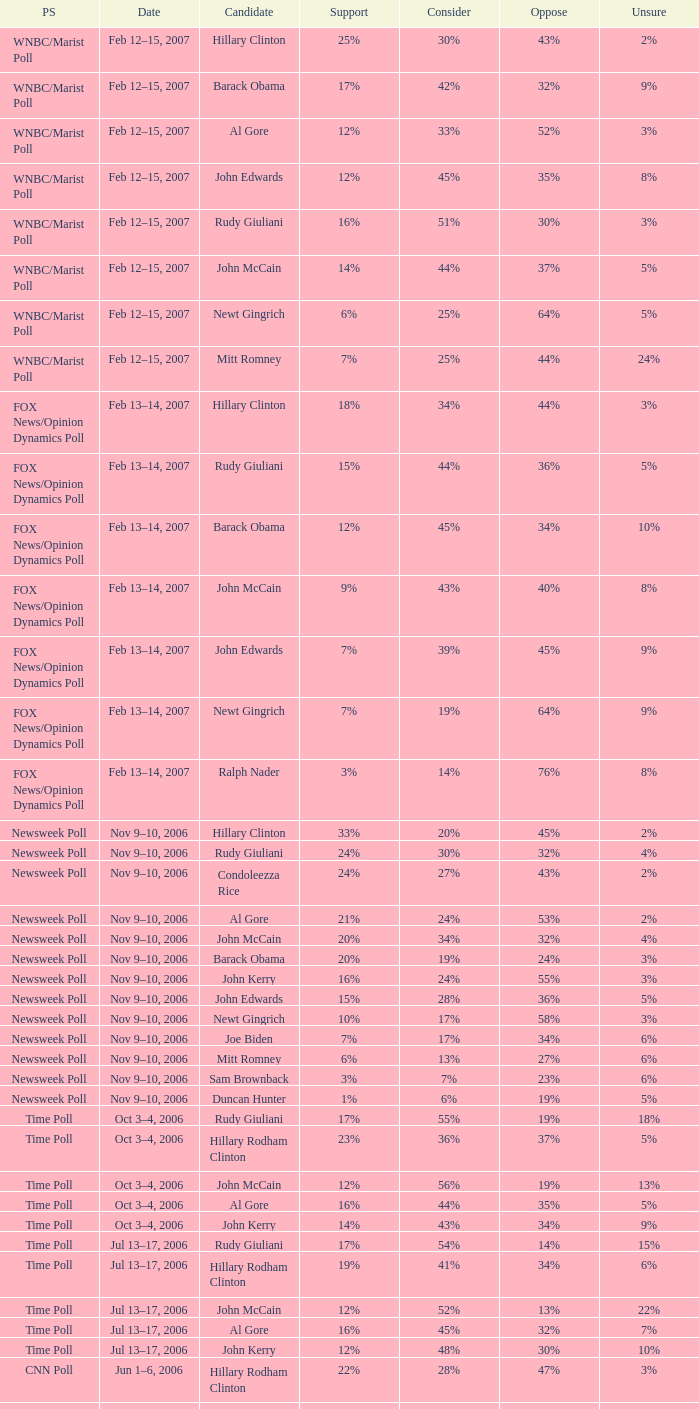What percentage of people were opposed to the candidate based on the WNBC/Marist poll that showed 8% of people were unsure? 35%. Could you parse the entire table? {'header': ['PS', 'Date', 'Candidate', 'Support', 'Consider', 'Oppose', 'Unsure'], 'rows': [['WNBC/Marist Poll', 'Feb 12–15, 2007', 'Hillary Clinton', '25%', '30%', '43%', '2%'], ['WNBC/Marist Poll', 'Feb 12–15, 2007', 'Barack Obama', '17%', '42%', '32%', '9%'], ['WNBC/Marist Poll', 'Feb 12–15, 2007', 'Al Gore', '12%', '33%', '52%', '3%'], ['WNBC/Marist Poll', 'Feb 12–15, 2007', 'John Edwards', '12%', '45%', '35%', '8%'], ['WNBC/Marist Poll', 'Feb 12–15, 2007', 'Rudy Giuliani', '16%', '51%', '30%', '3%'], ['WNBC/Marist Poll', 'Feb 12–15, 2007', 'John McCain', '14%', '44%', '37%', '5%'], ['WNBC/Marist Poll', 'Feb 12–15, 2007', 'Newt Gingrich', '6%', '25%', '64%', '5%'], ['WNBC/Marist Poll', 'Feb 12–15, 2007', 'Mitt Romney', '7%', '25%', '44%', '24%'], ['FOX News/Opinion Dynamics Poll', 'Feb 13–14, 2007', 'Hillary Clinton', '18%', '34%', '44%', '3%'], ['FOX News/Opinion Dynamics Poll', 'Feb 13–14, 2007', 'Rudy Giuliani', '15%', '44%', '36%', '5%'], ['FOX News/Opinion Dynamics Poll', 'Feb 13–14, 2007', 'Barack Obama', '12%', '45%', '34%', '10%'], ['FOX News/Opinion Dynamics Poll', 'Feb 13–14, 2007', 'John McCain', '9%', '43%', '40%', '8%'], ['FOX News/Opinion Dynamics Poll', 'Feb 13–14, 2007', 'John Edwards', '7%', '39%', '45%', '9%'], ['FOX News/Opinion Dynamics Poll', 'Feb 13–14, 2007', 'Newt Gingrich', '7%', '19%', '64%', '9%'], ['FOX News/Opinion Dynamics Poll', 'Feb 13–14, 2007', 'Ralph Nader', '3%', '14%', '76%', '8%'], ['Newsweek Poll', 'Nov 9–10, 2006', 'Hillary Clinton', '33%', '20%', '45%', '2%'], ['Newsweek Poll', 'Nov 9–10, 2006', 'Rudy Giuliani', '24%', '30%', '32%', '4%'], ['Newsweek Poll', 'Nov 9–10, 2006', 'Condoleezza Rice', '24%', '27%', '43%', '2%'], ['Newsweek Poll', 'Nov 9–10, 2006', 'Al Gore', '21%', '24%', '53%', '2%'], ['Newsweek Poll', 'Nov 9–10, 2006', 'John McCain', '20%', '34%', '32%', '4%'], ['Newsweek Poll', 'Nov 9–10, 2006', 'Barack Obama', '20%', '19%', '24%', '3%'], ['Newsweek Poll', 'Nov 9–10, 2006', 'John Kerry', '16%', '24%', '55%', '3%'], ['Newsweek Poll', 'Nov 9–10, 2006', 'John Edwards', '15%', '28%', '36%', '5%'], ['Newsweek Poll', 'Nov 9–10, 2006', 'Newt Gingrich', '10%', '17%', '58%', '3%'], ['Newsweek Poll', 'Nov 9–10, 2006', 'Joe Biden', '7%', '17%', '34%', '6%'], ['Newsweek Poll', 'Nov 9–10, 2006', 'Mitt Romney', '6%', '13%', '27%', '6%'], ['Newsweek Poll', 'Nov 9–10, 2006', 'Sam Brownback', '3%', '7%', '23%', '6%'], ['Newsweek Poll', 'Nov 9–10, 2006', 'Duncan Hunter', '1%', '6%', '19%', '5%'], ['Time Poll', 'Oct 3–4, 2006', 'Rudy Giuliani', '17%', '55%', '19%', '18%'], ['Time Poll', 'Oct 3–4, 2006', 'Hillary Rodham Clinton', '23%', '36%', '37%', '5%'], ['Time Poll', 'Oct 3–4, 2006', 'John McCain', '12%', '56%', '19%', '13%'], ['Time Poll', 'Oct 3–4, 2006', 'Al Gore', '16%', '44%', '35%', '5%'], ['Time Poll', 'Oct 3–4, 2006', 'John Kerry', '14%', '43%', '34%', '9%'], ['Time Poll', 'Jul 13–17, 2006', 'Rudy Giuliani', '17%', '54%', '14%', '15%'], ['Time Poll', 'Jul 13–17, 2006', 'Hillary Rodham Clinton', '19%', '41%', '34%', '6%'], ['Time Poll', 'Jul 13–17, 2006', 'John McCain', '12%', '52%', '13%', '22%'], ['Time Poll', 'Jul 13–17, 2006', 'Al Gore', '16%', '45%', '32%', '7%'], ['Time Poll', 'Jul 13–17, 2006', 'John Kerry', '12%', '48%', '30%', '10%'], ['CNN Poll', 'Jun 1–6, 2006', 'Hillary Rodham Clinton', '22%', '28%', '47%', '3%'], ['CNN Poll', 'Jun 1–6, 2006', 'Al Gore', '17%', '32%', '48%', '3%'], ['CNN Poll', 'Jun 1–6, 2006', 'John Kerry', '14%', '35%', '47%', '4%'], ['CNN Poll', 'Jun 1–6, 2006', 'Rudolph Giuliani', '19%', '45%', '30%', '6%'], ['CNN Poll', 'Jun 1–6, 2006', 'John McCain', '12%', '48%', '34%', '6%'], ['CNN Poll', 'Jun 1–6, 2006', 'Jeb Bush', '9%', '26%', '63%', '2%'], ['ABC News/Washington Post Poll', 'May 11–15, 2006', 'Hillary Clinton', '19%', '38%', '42%', '1%'], ['ABC News/Washington Post Poll', 'May 11–15, 2006', 'John McCain', '9%', '57%', '28%', '6%'], ['FOX News/Opinion Dynamics Poll', 'Feb 7–8, 2006', 'Hillary Clinton', '35%', '19%', '44%', '2%'], ['FOX News/Opinion Dynamics Poll', 'Feb 7–8, 2006', 'Rudy Giuliani', '33%', '38%', '24%', '6%'], ['FOX News/Opinion Dynamics Poll', 'Feb 7–8, 2006', 'John McCain', '30%', '40%', '22%', '7%'], ['FOX News/Opinion Dynamics Poll', 'Feb 7–8, 2006', 'John Kerry', '29%', '23%', '45%', '3%'], ['FOX News/Opinion Dynamics Poll', 'Feb 7–8, 2006', 'Condoleezza Rice', '14%', '38%', '46%', '3%'], ['CNN/USA Today/Gallup Poll', 'Jan 20–22, 2006', 'Hillary Rodham Clinton', '16%', '32%', '51%', '1%'], ['Diageo/Hotline Poll', 'Nov 11–15, 2005', 'John McCain', '23%', '46%', '15%', '15%'], ['CNN/USA Today/Gallup Poll', 'May 20–22, 2005', 'Hillary Rodham Clinton', '28%', '31%', '40%', '1%'], ['CNN/USA Today/Gallup Poll', 'Jun 9–10, 2003', 'Hillary Rodham Clinton', '20%', '33%', '45%', '2%']]} 